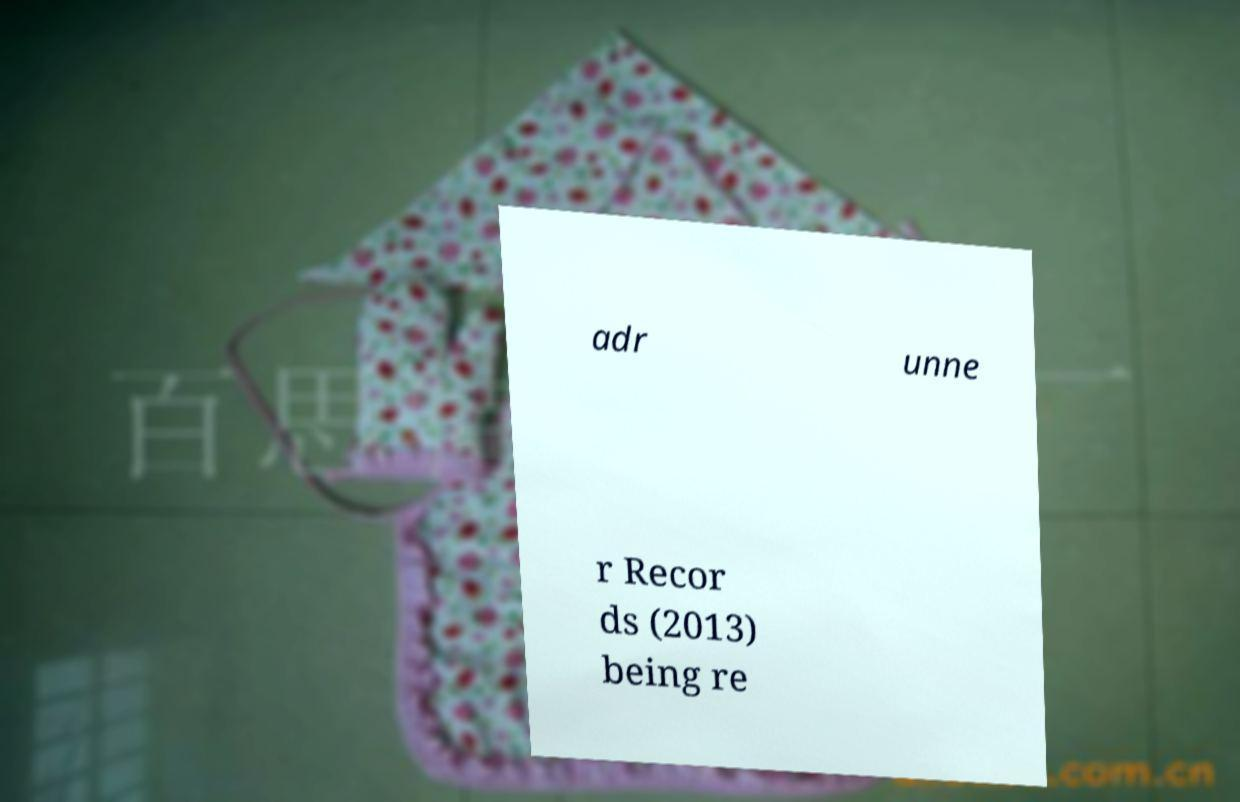There's text embedded in this image that I need extracted. Can you transcribe it verbatim? adr unne r Recor ds (2013) being re 